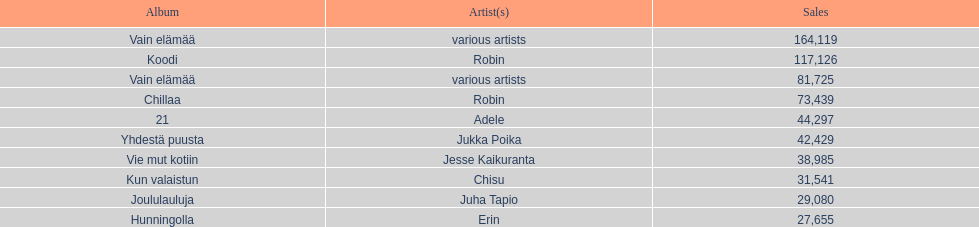Which album experienced the lowest amount of sales? Hunningolla. 